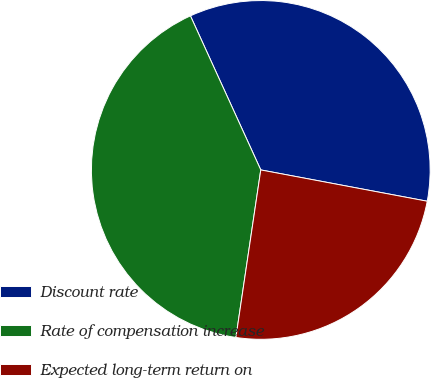<chart> <loc_0><loc_0><loc_500><loc_500><pie_chart><fcel>Discount rate<fcel>Rate of compensation increase<fcel>Expected long-term return on<nl><fcel>34.78%<fcel>40.84%<fcel>24.39%<nl></chart> 